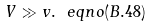Convert formula to latex. <formula><loc_0><loc_0><loc_500><loc_500>V \gg v . \ e q n o ( B . 4 8 )</formula> 